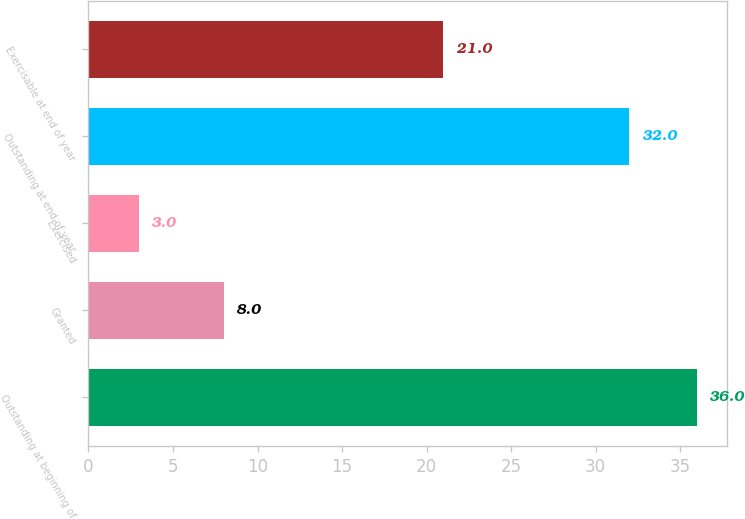Convert chart. <chart><loc_0><loc_0><loc_500><loc_500><bar_chart><fcel>Outstanding at beginning of<fcel>Granted<fcel>Exercised<fcel>Outstanding at end of year<fcel>Exercisable at end of year<nl><fcel>36<fcel>8<fcel>3<fcel>32<fcel>21<nl></chart> 